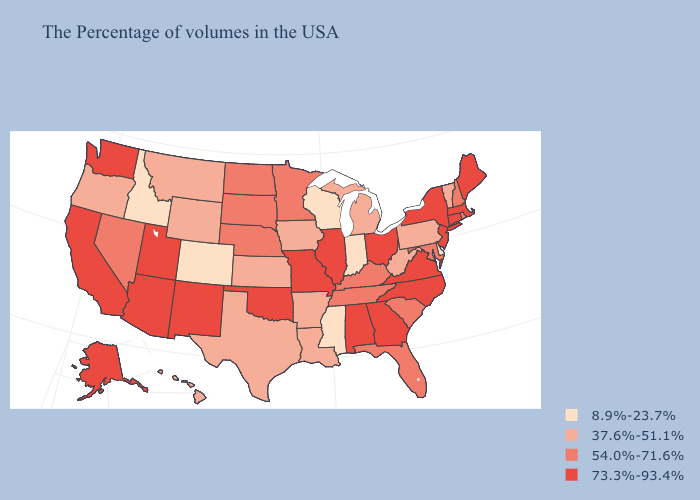Which states hav the highest value in the MidWest?
Write a very short answer. Ohio, Illinois, Missouri. Which states have the lowest value in the Northeast?
Concise answer only. Vermont, Pennsylvania. What is the lowest value in states that border New Mexico?
Short answer required. 8.9%-23.7%. What is the highest value in the West ?
Keep it brief. 73.3%-93.4%. Name the states that have a value in the range 37.6%-51.1%?
Concise answer only. Vermont, Pennsylvania, West Virginia, Michigan, Louisiana, Arkansas, Iowa, Kansas, Texas, Wyoming, Montana, Oregon, Hawaii. Among the states that border New Mexico , which have the highest value?
Keep it brief. Oklahoma, Utah, Arizona. Which states hav the highest value in the West?
Write a very short answer. New Mexico, Utah, Arizona, California, Washington, Alaska. What is the value of Arkansas?
Be succinct. 37.6%-51.1%. Is the legend a continuous bar?
Write a very short answer. No. Does Wisconsin have the lowest value in the USA?
Give a very brief answer. Yes. Name the states that have a value in the range 37.6%-51.1%?
Concise answer only. Vermont, Pennsylvania, West Virginia, Michigan, Louisiana, Arkansas, Iowa, Kansas, Texas, Wyoming, Montana, Oregon, Hawaii. Does Hawaii have the highest value in the USA?
Give a very brief answer. No. Does New Jersey have the highest value in the USA?
Be succinct. Yes. Among the states that border Iowa , does Minnesota have the lowest value?
Keep it brief. No. Does the map have missing data?
Answer briefly. No. 